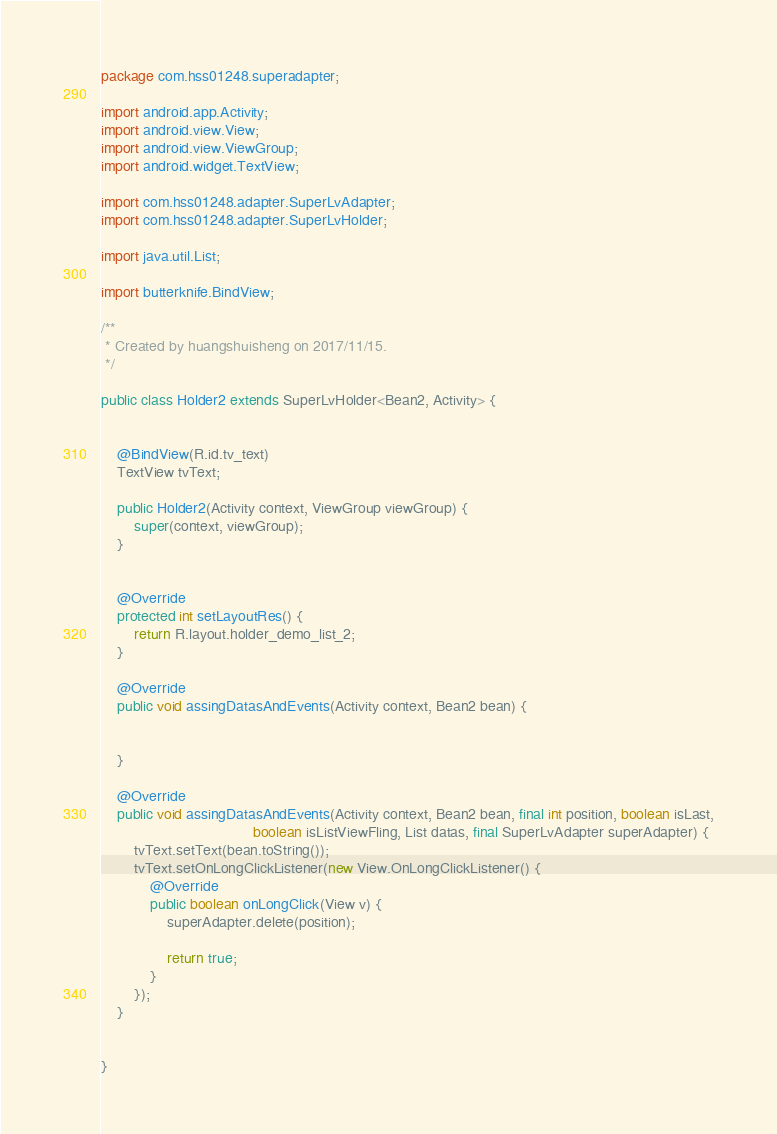Convert code to text. <code><loc_0><loc_0><loc_500><loc_500><_Java_>package com.hss01248.superadapter;

import android.app.Activity;
import android.view.View;
import android.view.ViewGroup;
import android.widget.TextView;

import com.hss01248.adapter.SuperLvAdapter;
import com.hss01248.adapter.SuperLvHolder;

import java.util.List;

import butterknife.BindView;

/**
 * Created by huangshuisheng on 2017/11/15.
 */

public class Holder2 extends SuperLvHolder<Bean2, Activity> {


    @BindView(R.id.tv_text)
    TextView tvText;

    public Holder2(Activity context, ViewGroup viewGroup) {
        super(context, viewGroup);
    }


    @Override
    protected int setLayoutRes() {
        return R.layout.holder_demo_list_2;
    }

    @Override
    public void assingDatasAndEvents(Activity context, Bean2 bean) {


    }

    @Override
    public void assingDatasAndEvents(Activity context, Bean2 bean, final int position, boolean isLast,
                                     boolean isListViewFling, List datas, final SuperLvAdapter superAdapter) {
        tvText.setText(bean.toString());
        tvText.setOnLongClickListener(new View.OnLongClickListener() {
            @Override
            public boolean onLongClick(View v) {
                superAdapter.delete(position);

                return true;
            }
        });
    }


}
</code> 